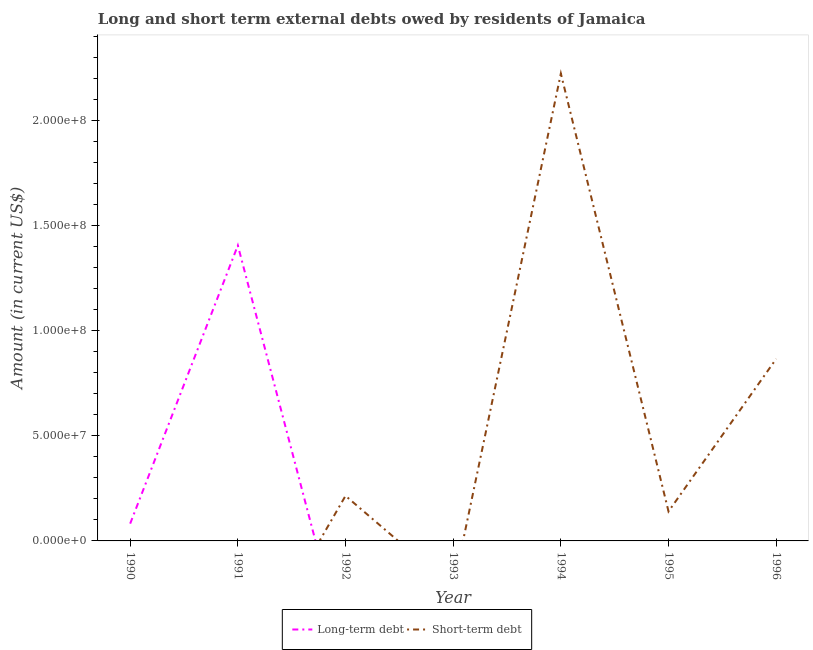Is the number of lines equal to the number of legend labels?
Make the answer very short. No. What is the long-term debts owed by residents in 1991?
Provide a short and direct response. 1.41e+08. Across all years, what is the maximum short-term debts owed by residents?
Offer a very short reply. 2.22e+08. What is the total long-term debts owed by residents in the graph?
Ensure brevity in your answer.  1.49e+08. What is the difference between the long-term debts owed by residents in 1991 and the short-term debts owed by residents in 1995?
Ensure brevity in your answer.  1.26e+08. What is the average short-term debts owed by residents per year?
Ensure brevity in your answer.  4.92e+07. What is the ratio of the short-term debts owed by residents in 1994 to that in 1995?
Your response must be concise. 15.84. What is the difference between the highest and the second highest short-term debts owed by residents?
Offer a terse response. 1.36e+08. What is the difference between the highest and the lowest long-term debts owed by residents?
Give a very brief answer. 1.41e+08. Is the short-term debts owed by residents strictly greater than the long-term debts owed by residents over the years?
Provide a short and direct response. No. Is the long-term debts owed by residents strictly less than the short-term debts owed by residents over the years?
Ensure brevity in your answer.  No. What is the difference between two consecutive major ticks on the Y-axis?
Your answer should be very brief. 5.00e+07. Are the values on the major ticks of Y-axis written in scientific E-notation?
Provide a succinct answer. Yes. Does the graph contain any zero values?
Keep it short and to the point. Yes. Where does the legend appear in the graph?
Offer a very short reply. Bottom center. How are the legend labels stacked?
Make the answer very short. Horizontal. What is the title of the graph?
Give a very brief answer. Long and short term external debts owed by residents of Jamaica. What is the label or title of the X-axis?
Make the answer very short. Year. What is the Amount (in current US$) in Long-term debt in 1990?
Provide a short and direct response. 8.22e+06. What is the Amount (in current US$) of Short-term debt in 1990?
Keep it short and to the point. 0. What is the Amount (in current US$) of Long-term debt in 1991?
Ensure brevity in your answer.  1.41e+08. What is the Amount (in current US$) in Short-term debt in 1991?
Provide a short and direct response. 0. What is the Amount (in current US$) of Long-term debt in 1992?
Your response must be concise. 0. What is the Amount (in current US$) of Short-term debt in 1992?
Make the answer very short. 2.14e+07. What is the Amount (in current US$) of Short-term debt in 1993?
Your response must be concise. 0. What is the Amount (in current US$) of Short-term debt in 1994?
Give a very brief answer. 2.22e+08. What is the Amount (in current US$) in Long-term debt in 1995?
Provide a succinct answer. 0. What is the Amount (in current US$) in Short-term debt in 1995?
Make the answer very short. 1.40e+07. What is the Amount (in current US$) of Short-term debt in 1996?
Your response must be concise. 8.66e+07. Across all years, what is the maximum Amount (in current US$) of Long-term debt?
Offer a very short reply. 1.41e+08. Across all years, what is the maximum Amount (in current US$) in Short-term debt?
Make the answer very short. 2.22e+08. Across all years, what is the minimum Amount (in current US$) in Long-term debt?
Your response must be concise. 0. What is the total Amount (in current US$) in Long-term debt in the graph?
Provide a short and direct response. 1.49e+08. What is the total Amount (in current US$) in Short-term debt in the graph?
Offer a very short reply. 3.44e+08. What is the difference between the Amount (in current US$) in Long-term debt in 1990 and that in 1991?
Make the answer very short. -1.32e+08. What is the difference between the Amount (in current US$) in Short-term debt in 1992 and that in 1994?
Keep it short and to the point. -2.01e+08. What is the difference between the Amount (in current US$) of Short-term debt in 1992 and that in 1995?
Make the answer very short. 7.42e+06. What is the difference between the Amount (in current US$) of Short-term debt in 1992 and that in 1996?
Provide a succinct answer. -6.52e+07. What is the difference between the Amount (in current US$) in Short-term debt in 1994 and that in 1995?
Your answer should be very brief. 2.08e+08. What is the difference between the Amount (in current US$) in Short-term debt in 1994 and that in 1996?
Ensure brevity in your answer.  1.36e+08. What is the difference between the Amount (in current US$) in Short-term debt in 1995 and that in 1996?
Your answer should be very brief. -7.26e+07. What is the difference between the Amount (in current US$) of Long-term debt in 1990 and the Amount (in current US$) of Short-term debt in 1992?
Provide a succinct answer. -1.32e+07. What is the difference between the Amount (in current US$) in Long-term debt in 1990 and the Amount (in current US$) in Short-term debt in 1994?
Give a very brief answer. -2.14e+08. What is the difference between the Amount (in current US$) in Long-term debt in 1990 and the Amount (in current US$) in Short-term debt in 1995?
Provide a short and direct response. -5.81e+06. What is the difference between the Amount (in current US$) of Long-term debt in 1990 and the Amount (in current US$) of Short-term debt in 1996?
Offer a very short reply. -7.84e+07. What is the difference between the Amount (in current US$) of Long-term debt in 1991 and the Amount (in current US$) of Short-term debt in 1992?
Give a very brief answer. 1.19e+08. What is the difference between the Amount (in current US$) in Long-term debt in 1991 and the Amount (in current US$) in Short-term debt in 1994?
Make the answer very short. -8.18e+07. What is the difference between the Amount (in current US$) of Long-term debt in 1991 and the Amount (in current US$) of Short-term debt in 1995?
Provide a short and direct response. 1.26e+08. What is the difference between the Amount (in current US$) in Long-term debt in 1991 and the Amount (in current US$) in Short-term debt in 1996?
Ensure brevity in your answer.  5.39e+07. What is the average Amount (in current US$) in Long-term debt per year?
Provide a succinct answer. 2.12e+07. What is the average Amount (in current US$) in Short-term debt per year?
Offer a terse response. 4.92e+07. What is the ratio of the Amount (in current US$) in Long-term debt in 1990 to that in 1991?
Give a very brief answer. 0.06. What is the ratio of the Amount (in current US$) in Short-term debt in 1992 to that in 1994?
Provide a short and direct response. 0.1. What is the ratio of the Amount (in current US$) in Short-term debt in 1992 to that in 1995?
Your response must be concise. 1.53. What is the ratio of the Amount (in current US$) in Short-term debt in 1992 to that in 1996?
Offer a terse response. 0.25. What is the ratio of the Amount (in current US$) of Short-term debt in 1994 to that in 1995?
Keep it short and to the point. 15.84. What is the ratio of the Amount (in current US$) of Short-term debt in 1994 to that in 1996?
Give a very brief answer. 2.57. What is the ratio of the Amount (in current US$) of Short-term debt in 1995 to that in 1996?
Offer a terse response. 0.16. What is the difference between the highest and the second highest Amount (in current US$) of Short-term debt?
Provide a succinct answer. 1.36e+08. What is the difference between the highest and the lowest Amount (in current US$) of Long-term debt?
Your answer should be very brief. 1.41e+08. What is the difference between the highest and the lowest Amount (in current US$) of Short-term debt?
Ensure brevity in your answer.  2.22e+08. 